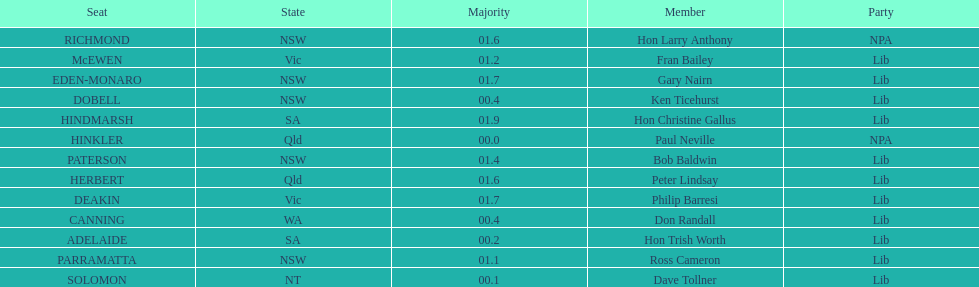Tell me the number of seats from nsw? 5. 